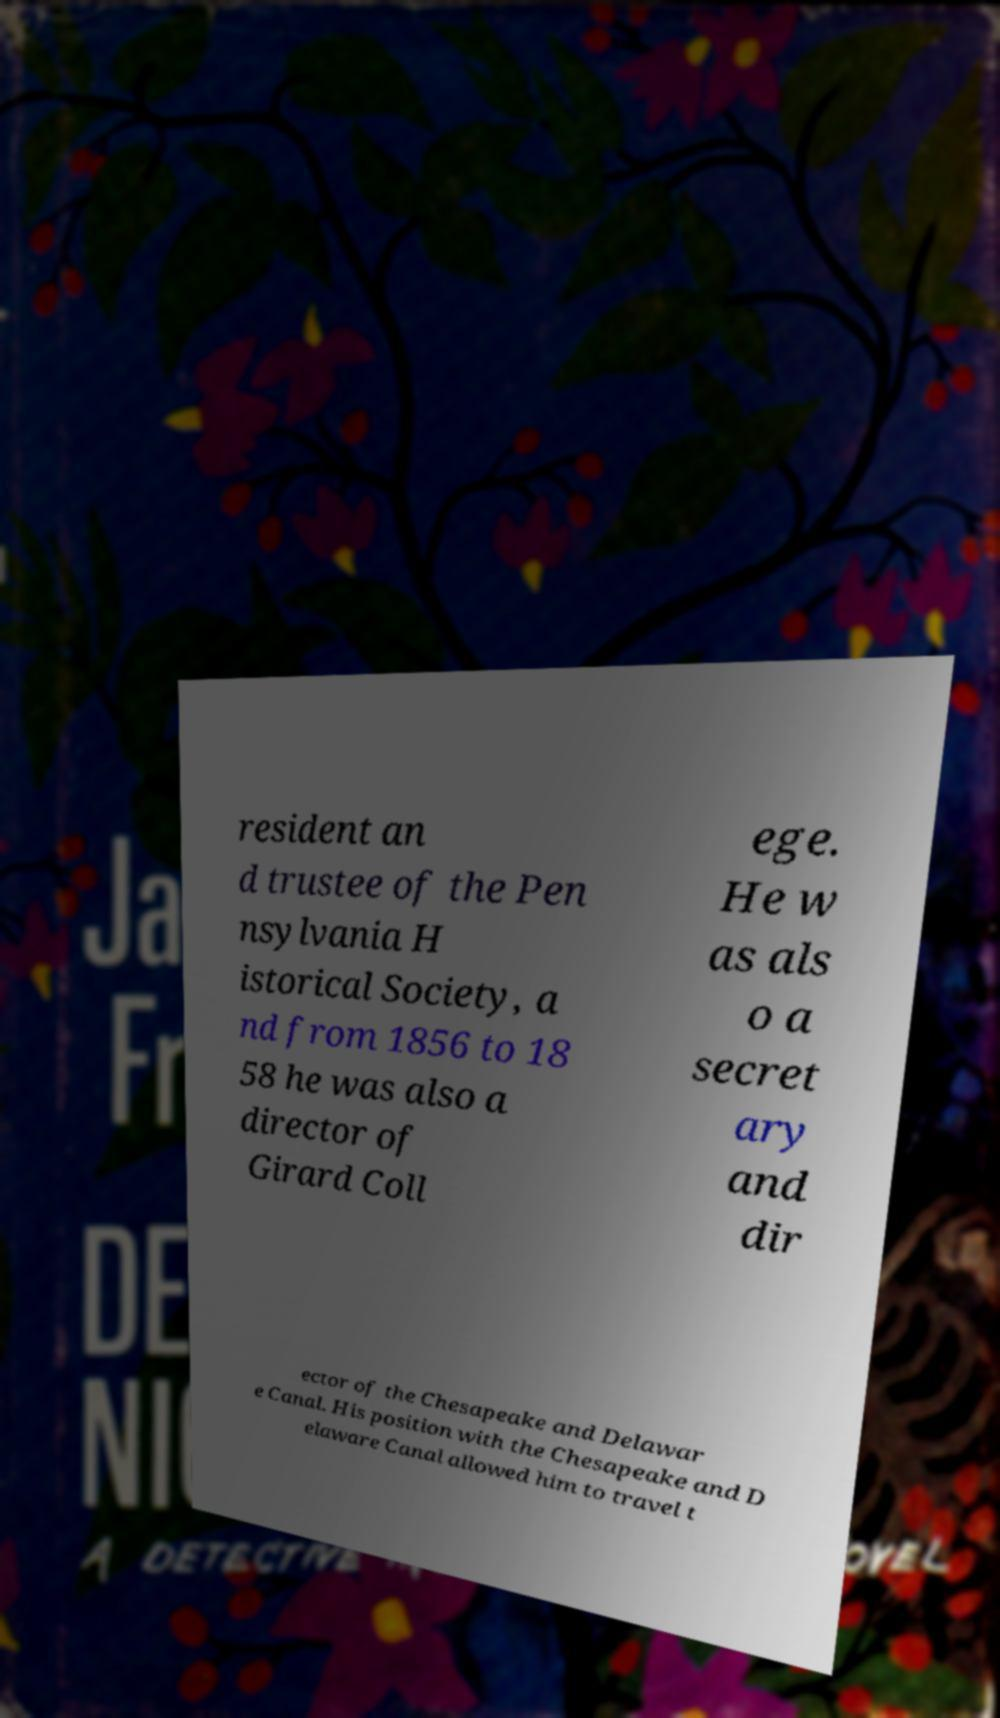What messages or text are displayed in this image? I need them in a readable, typed format. resident an d trustee of the Pen nsylvania H istorical Society, a nd from 1856 to 18 58 he was also a director of Girard Coll ege. He w as als o a secret ary and dir ector of the Chesapeake and Delawar e Canal. His position with the Chesapeake and D elaware Canal allowed him to travel t 